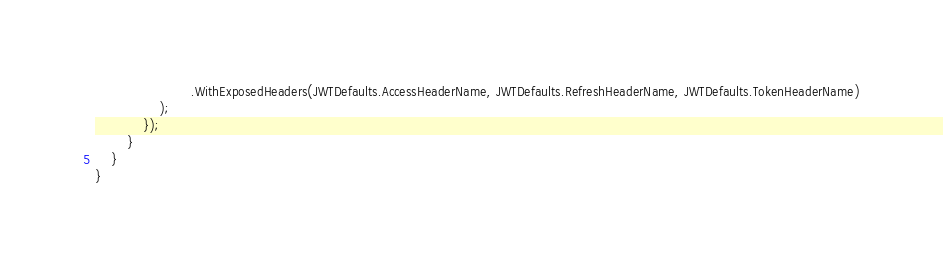Convert code to text. <code><loc_0><loc_0><loc_500><loc_500><_C#_>                        .WithExposedHeaders(JWTDefaults.AccessHeaderName, JWTDefaults.RefreshHeaderName, JWTDefaults.TokenHeaderName)
                );
            });
        }
    }
}</code> 